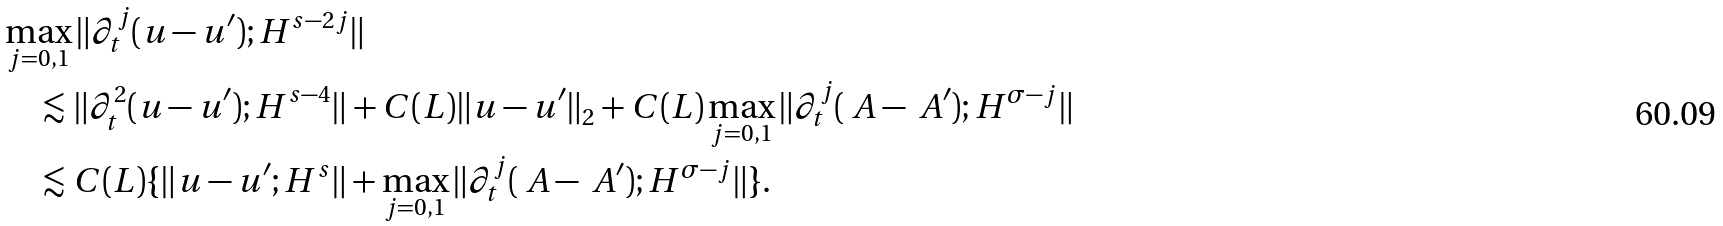<formula> <loc_0><loc_0><loc_500><loc_500>& \max _ { j = 0 , 1 } \| \partial _ { t } ^ { j } ( u - u ^ { \prime } ) ; H ^ { s - 2 j } \| \\ & \quad \lesssim \| \partial _ { t } ^ { 2 } ( u - u ^ { \prime } ) ; H ^ { s - 4 } \| + C ( L ) \| u - u ^ { \prime } \| _ { 2 } + C ( L ) \max _ { j = 0 , 1 } \| \partial _ { t } ^ { j } ( \ A - \ A ^ { \prime } ) ; H ^ { \sigma - j } \| \\ & \quad \lesssim C ( L ) \{ \| u - u ^ { \prime } ; H ^ { s } \| + \max _ { j = 0 , 1 } \| \partial _ { t } ^ { j } ( \ A - \ A ^ { \prime } ) ; H ^ { \sigma - j } \| \} .</formula> 